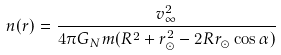<formula> <loc_0><loc_0><loc_500><loc_500>n ( r ) = \frac { v _ { \infty } ^ { 2 } } { 4 \pi G _ { N } m ( R ^ { 2 } + r _ { \odot } ^ { 2 } - 2 R r _ { \odot } \cos \alpha ) }</formula> 